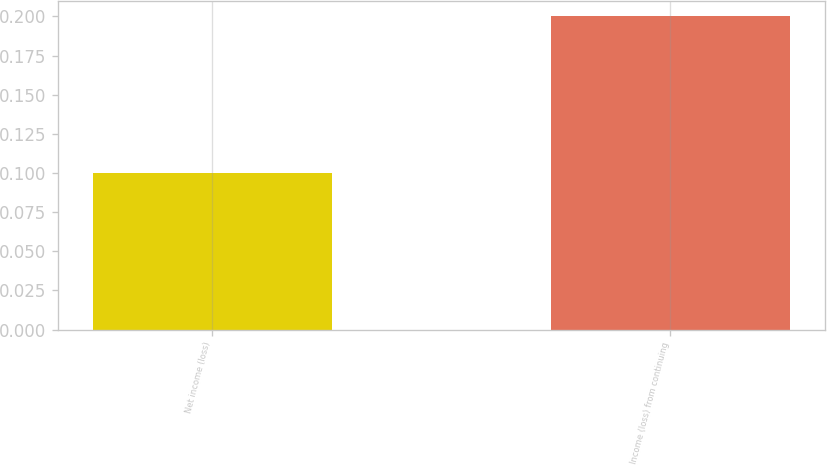<chart> <loc_0><loc_0><loc_500><loc_500><bar_chart><fcel>Net income (loss)<fcel>Income (loss) from continuing<nl><fcel>0.1<fcel>0.2<nl></chart> 